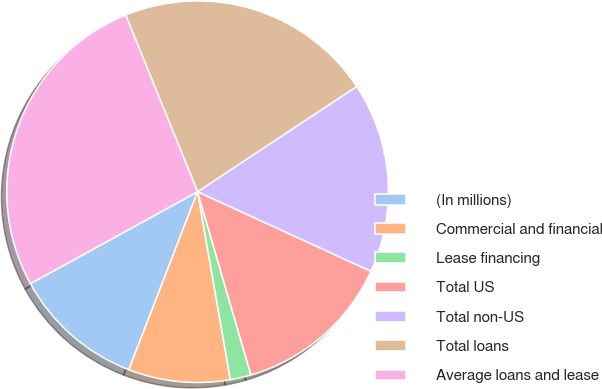<chart> <loc_0><loc_0><loc_500><loc_500><pie_chart><fcel>(In millions)<fcel>Commercial and financial<fcel>Lease financing<fcel>Total US<fcel>Total non-US<fcel>Total loans<fcel>Average loans and lease<nl><fcel>11.13%<fcel>8.62%<fcel>1.76%<fcel>13.64%<fcel>16.15%<fcel>21.85%<fcel>26.85%<nl></chart> 